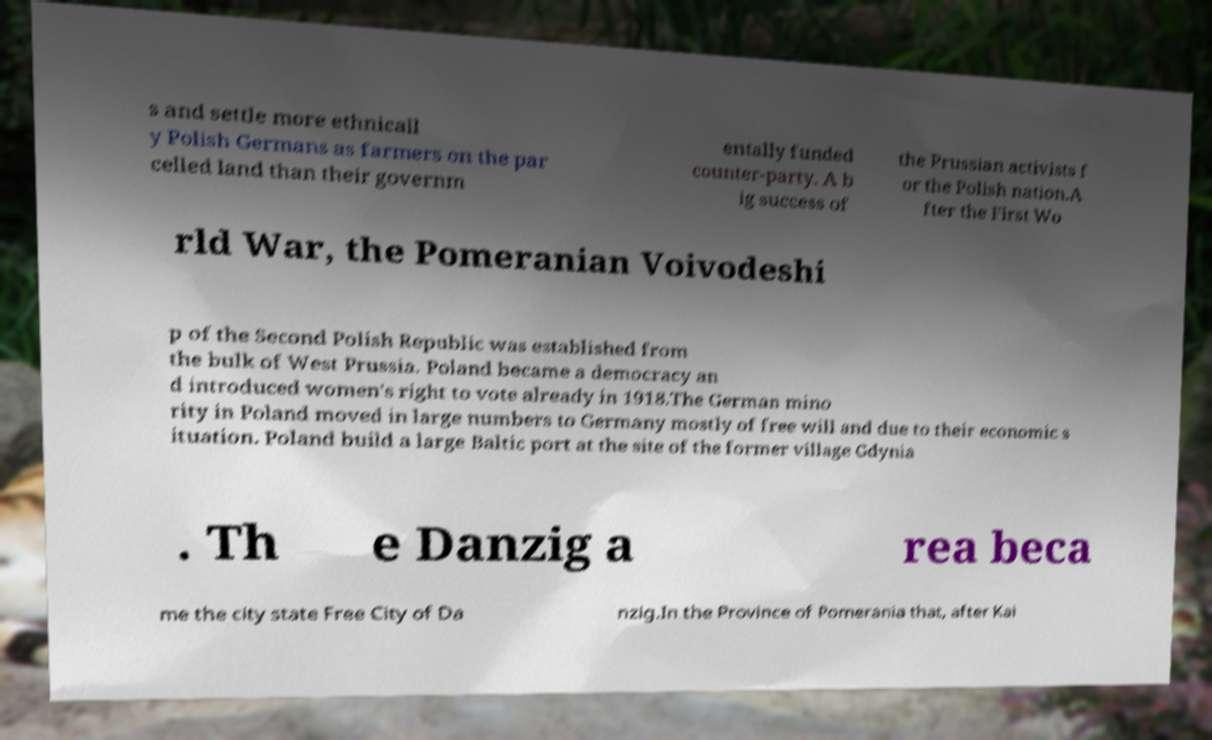Can you accurately transcribe the text from the provided image for me? s and settle more ethnicall y Polish Germans as farmers on the par celled land than their governm entally funded counter-party. A b ig success of the Prussian activists f or the Polish nation.A fter the First Wo rld War, the Pomeranian Voivodeshi p of the Second Polish Republic was established from the bulk of West Prussia. Poland became a democracy an d introduced women's right to vote already in 1918.The German mino rity in Poland moved in large numbers to Germany mostly of free will and due to their economic s ituation. Poland build a large Baltic port at the site of the former village Gdynia . Th e Danzig a rea beca me the city state Free City of Da nzig.In the Province of Pomerania that, after Kai 